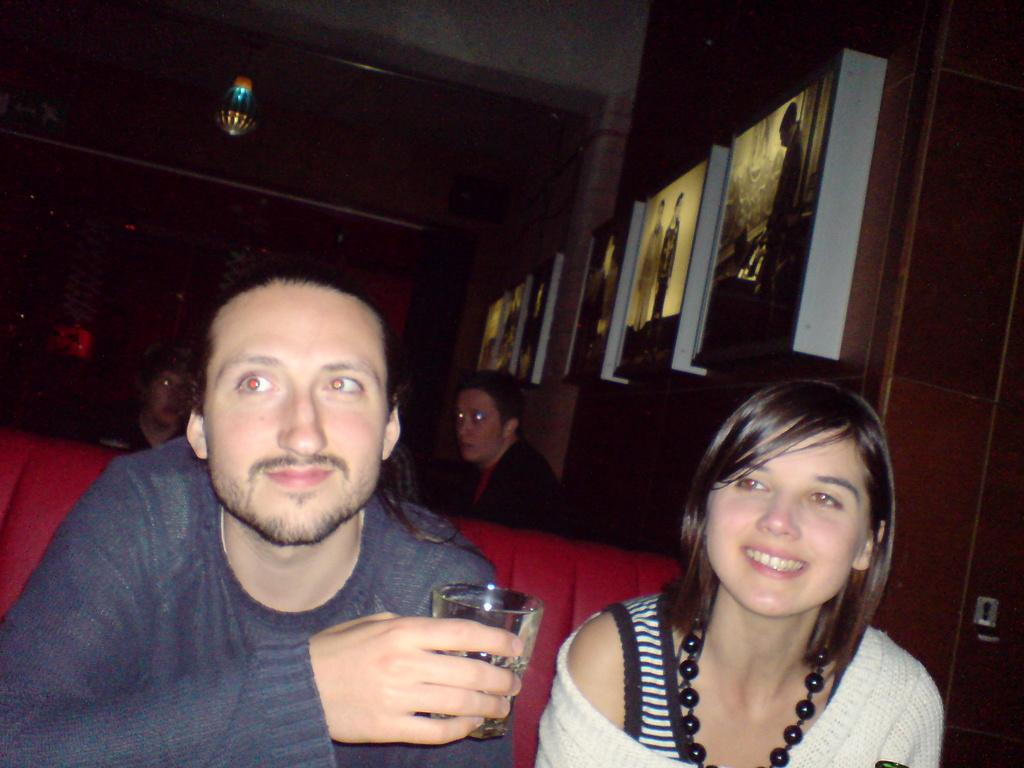What are the people in the image doing? The people in the image are seated. What is the man holding in his hand? The man is holding a glass in his hand. What can be seen on the wall in the image? There are photo frames on the wall. What is the woman wearing that is noticeable? The woman is wearing an ornament. What type of fruit is being used as a toothpaste in the image? There is no fruit or toothpaste present in the image. Is there a ship visible in the image? No, there is no ship visible in the image. 